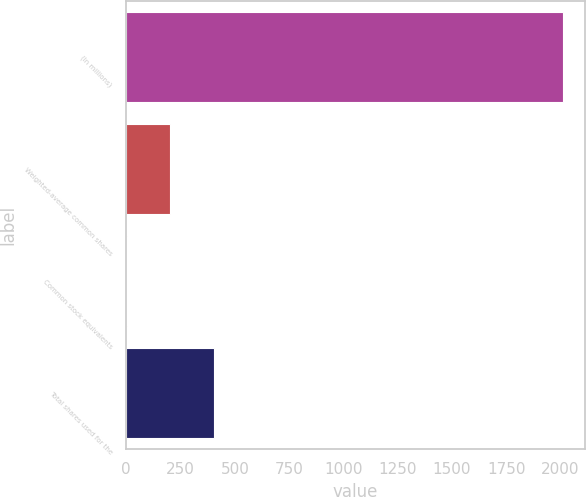<chart> <loc_0><loc_0><loc_500><loc_500><bar_chart><fcel>(In millions)<fcel>Weighted-average common shares<fcel>Common stock equivalents<fcel>Total shares used for the<nl><fcel>2010<fcel>202.17<fcel>1.3<fcel>403.04<nl></chart> 